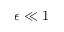Convert formula to latex. <formula><loc_0><loc_0><loc_500><loc_500>\epsilon \ll 1</formula> 